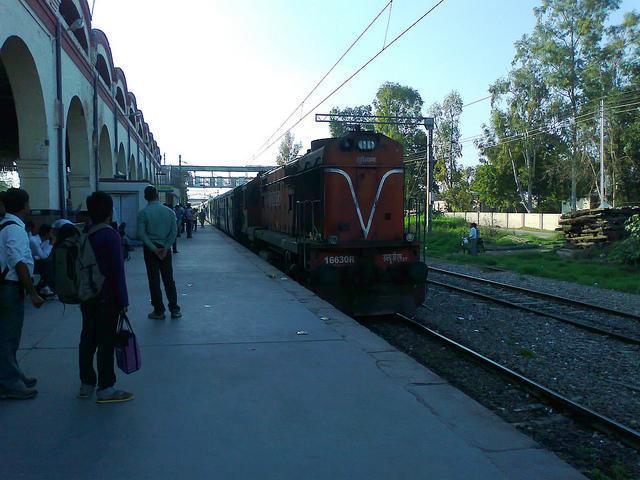How many people can you see?
Give a very brief answer. 3. 